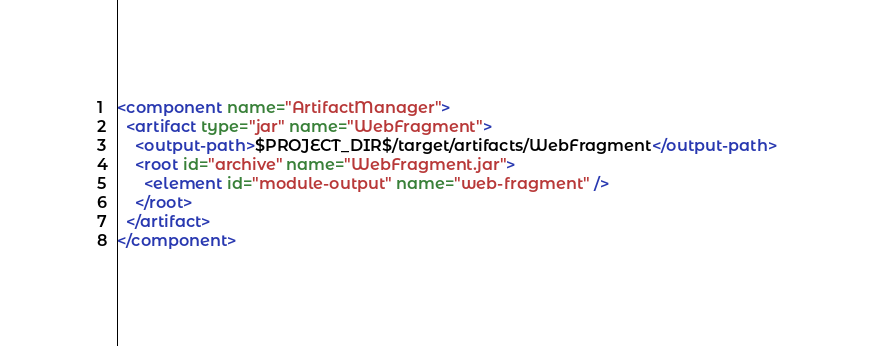<code> <loc_0><loc_0><loc_500><loc_500><_XML_><component name="ArtifactManager">
  <artifact type="jar" name="WebFragment">
    <output-path>$PROJECT_DIR$/target/artifacts/WebFragment</output-path>
    <root id="archive" name="WebFragment.jar">
      <element id="module-output" name="web-fragment" />
    </root>
  </artifact>
</component></code> 